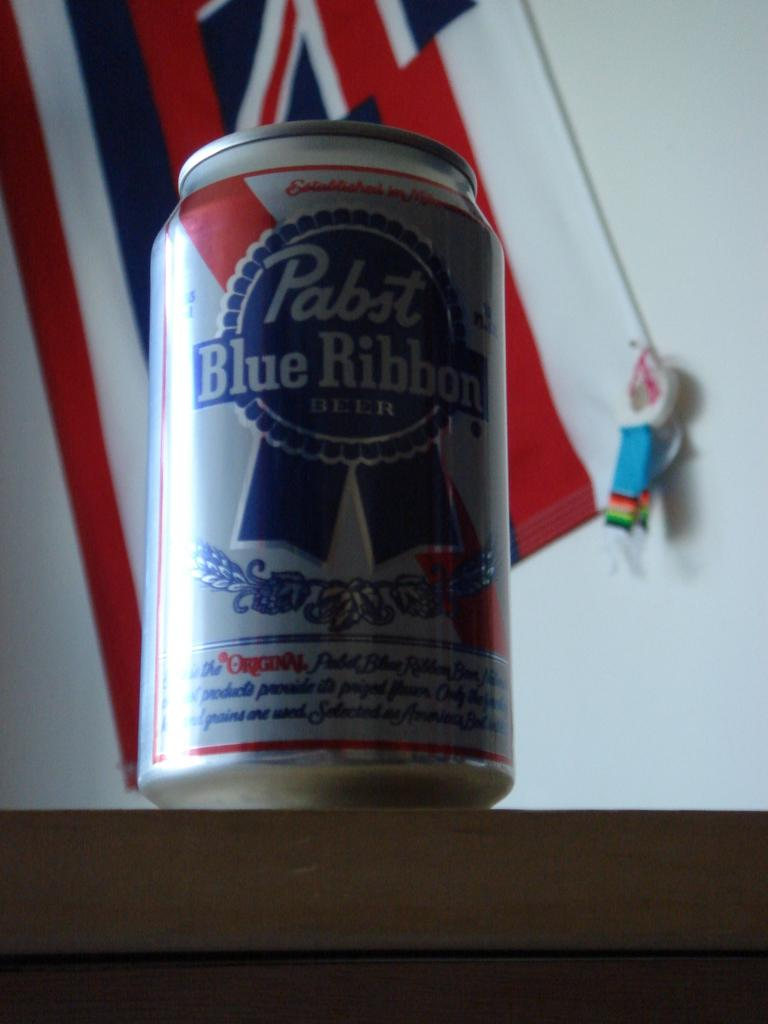Provide a one-sentence caption for the provided image. A can of Pabst Blue Ribbon sits on a counter in front of a flag. 